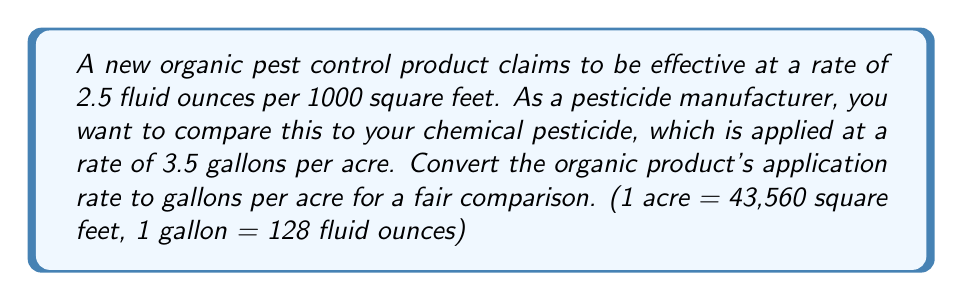Provide a solution to this math problem. To solve this problem, we need to convert the organic product's application rate from fluid ounces per 1000 square feet to gallons per acre. Let's break it down step by step:

1. First, let's find out how many fluid ounces are needed for one acre:
   $$ \frac{2.5 \text{ fl oz}}{1000 \text{ sq ft}} \times \frac{43,560 \text{ sq ft}}{1 \text{ acre}} = \frac{2.5 \times 43,560}{1000} \text{ fl oz/acre} = 108.9 \text{ fl oz/acre} $$

2. Now, let's convert fluid ounces to gallons:
   $$ \frac{108.9 \text{ fl oz}}{128 \text{ fl oz/gallon}} = 0.8508 \text{ gallons/acre} $$

3. Rounding to two decimal places:
   $$ 0.8508 \text{ gallons/acre} \approx 0.85 \text{ gallons/acre} $$

This conversion allows us to compare the organic product's application rate (0.85 gallons/acre) to the chemical pesticide's rate (3.5 gallons/acre).
Answer: 0.85 gallons per acre 